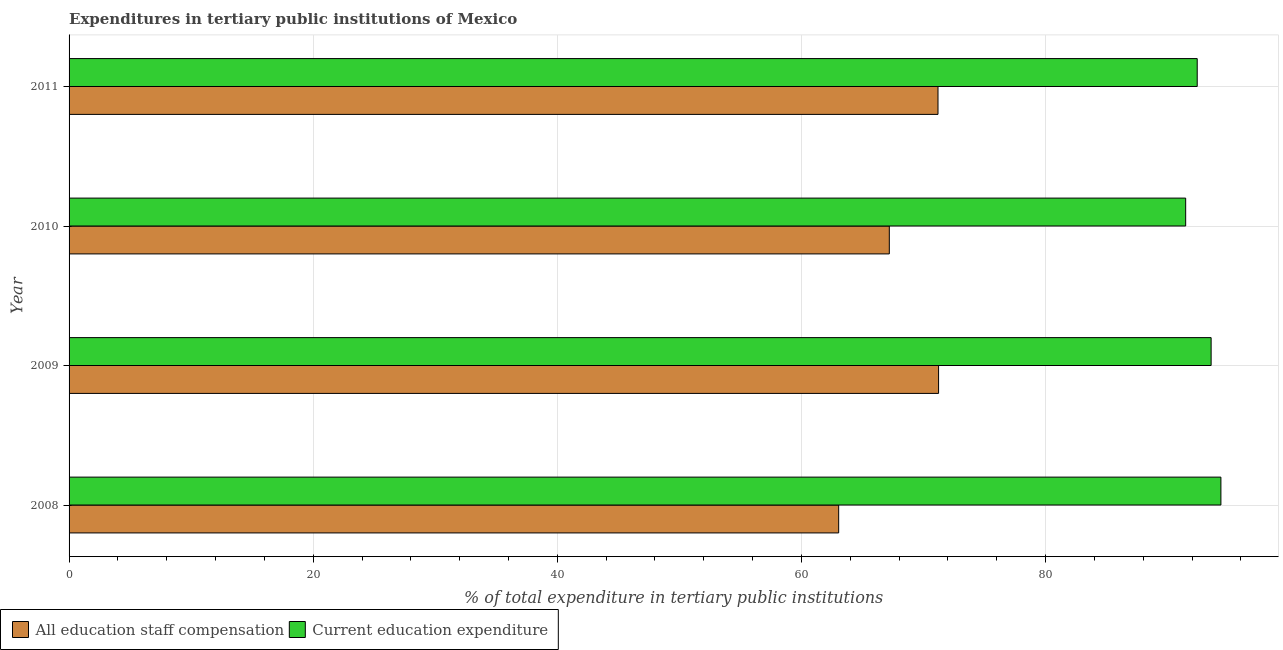How many different coloured bars are there?
Give a very brief answer. 2. How many groups of bars are there?
Keep it short and to the point. 4. Are the number of bars on each tick of the Y-axis equal?
Your answer should be very brief. Yes. How many bars are there on the 2nd tick from the top?
Ensure brevity in your answer.  2. What is the label of the 2nd group of bars from the top?
Offer a terse response. 2010. In how many cases, is the number of bars for a given year not equal to the number of legend labels?
Your response must be concise. 0. What is the expenditure in education in 2010?
Offer a terse response. 91.48. Across all years, what is the maximum expenditure in education?
Your response must be concise. 94.36. Across all years, what is the minimum expenditure in education?
Give a very brief answer. 91.48. In which year was the expenditure in education minimum?
Your response must be concise. 2010. What is the total expenditure in staff compensation in the graph?
Offer a very short reply. 272.67. What is the difference between the expenditure in education in 2008 and that in 2009?
Make the answer very short. 0.8. What is the difference between the expenditure in staff compensation in 2011 and the expenditure in education in 2008?
Offer a very short reply. -23.18. What is the average expenditure in staff compensation per year?
Offer a terse response. 68.17. In the year 2009, what is the difference between the expenditure in education and expenditure in staff compensation?
Your answer should be compact. 22.33. In how many years, is the expenditure in education greater than 68 %?
Your answer should be very brief. 4. What is the ratio of the expenditure in staff compensation in 2008 to that in 2010?
Provide a short and direct response. 0.94. Is the expenditure in staff compensation in 2008 less than that in 2011?
Ensure brevity in your answer.  Yes. Is the difference between the expenditure in education in 2009 and 2010 greater than the difference between the expenditure in staff compensation in 2009 and 2010?
Give a very brief answer. No. What is the difference between the highest and the second highest expenditure in staff compensation?
Make the answer very short. 0.05. What is the difference between the highest and the lowest expenditure in staff compensation?
Your response must be concise. 8.18. In how many years, is the expenditure in staff compensation greater than the average expenditure in staff compensation taken over all years?
Offer a very short reply. 2. What does the 1st bar from the top in 2009 represents?
Your answer should be very brief. Current education expenditure. What does the 1st bar from the bottom in 2008 represents?
Make the answer very short. All education staff compensation. How many bars are there?
Your answer should be compact. 8. Are the values on the major ticks of X-axis written in scientific E-notation?
Give a very brief answer. No. Does the graph contain any zero values?
Provide a short and direct response. No. How are the legend labels stacked?
Offer a very short reply. Horizontal. What is the title of the graph?
Provide a succinct answer. Expenditures in tertiary public institutions of Mexico. What is the label or title of the X-axis?
Provide a short and direct response. % of total expenditure in tertiary public institutions. What is the % of total expenditure in tertiary public institutions in All education staff compensation in 2008?
Make the answer very short. 63.05. What is the % of total expenditure in tertiary public institutions in Current education expenditure in 2008?
Ensure brevity in your answer.  94.36. What is the % of total expenditure in tertiary public institutions of All education staff compensation in 2009?
Provide a succinct answer. 71.23. What is the % of total expenditure in tertiary public institutions in Current education expenditure in 2009?
Provide a short and direct response. 93.56. What is the % of total expenditure in tertiary public institutions of All education staff compensation in 2010?
Offer a terse response. 67.2. What is the % of total expenditure in tertiary public institutions in Current education expenditure in 2010?
Offer a terse response. 91.48. What is the % of total expenditure in tertiary public institutions of All education staff compensation in 2011?
Provide a short and direct response. 71.19. What is the % of total expenditure in tertiary public institutions of Current education expenditure in 2011?
Provide a short and direct response. 92.42. Across all years, what is the maximum % of total expenditure in tertiary public institutions in All education staff compensation?
Provide a short and direct response. 71.23. Across all years, what is the maximum % of total expenditure in tertiary public institutions in Current education expenditure?
Your answer should be compact. 94.36. Across all years, what is the minimum % of total expenditure in tertiary public institutions in All education staff compensation?
Your answer should be compact. 63.05. Across all years, what is the minimum % of total expenditure in tertiary public institutions of Current education expenditure?
Keep it short and to the point. 91.48. What is the total % of total expenditure in tertiary public institutions of All education staff compensation in the graph?
Give a very brief answer. 272.67. What is the total % of total expenditure in tertiary public institutions of Current education expenditure in the graph?
Offer a terse response. 371.82. What is the difference between the % of total expenditure in tertiary public institutions in All education staff compensation in 2008 and that in 2009?
Offer a very short reply. -8.18. What is the difference between the % of total expenditure in tertiary public institutions of Current education expenditure in 2008 and that in 2009?
Provide a short and direct response. 0.8. What is the difference between the % of total expenditure in tertiary public institutions in All education staff compensation in 2008 and that in 2010?
Offer a very short reply. -4.15. What is the difference between the % of total expenditure in tertiary public institutions of Current education expenditure in 2008 and that in 2010?
Offer a very short reply. 2.89. What is the difference between the % of total expenditure in tertiary public institutions of All education staff compensation in 2008 and that in 2011?
Keep it short and to the point. -8.14. What is the difference between the % of total expenditure in tertiary public institutions in Current education expenditure in 2008 and that in 2011?
Your answer should be very brief. 1.94. What is the difference between the % of total expenditure in tertiary public institutions in All education staff compensation in 2009 and that in 2010?
Your answer should be compact. 4.04. What is the difference between the % of total expenditure in tertiary public institutions in Current education expenditure in 2009 and that in 2010?
Provide a short and direct response. 2.09. What is the difference between the % of total expenditure in tertiary public institutions of All education staff compensation in 2009 and that in 2011?
Ensure brevity in your answer.  0.05. What is the difference between the % of total expenditure in tertiary public institutions in Current education expenditure in 2009 and that in 2011?
Provide a succinct answer. 1.14. What is the difference between the % of total expenditure in tertiary public institutions in All education staff compensation in 2010 and that in 2011?
Give a very brief answer. -3.99. What is the difference between the % of total expenditure in tertiary public institutions of Current education expenditure in 2010 and that in 2011?
Your answer should be very brief. -0.95. What is the difference between the % of total expenditure in tertiary public institutions in All education staff compensation in 2008 and the % of total expenditure in tertiary public institutions in Current education expenditure in 2009?
Ensure brevity in your answer.  -30.51. What is the difference between the % of total expenditure in tertiary public institutions of All education staff compensation in 2008 and the % of total expenditure in tertiary public institutions of Current education expenditure in 2010?
Give a very brief answer. -28.43. What is the difference between the % of total expenditure in tertiary public institutions of All education staff compensation in 2008 and the % of total expenditure in tertiary public institutions of Current education expenditure in 2011?
Offer a terse response. -29.37. What is the difference between the % of total expenditure in tertiary public institutions in All education staff compensation in 2009 and the % of total expenditure in tertiary public institutions in Current education expenditure in 2010?
Your response must be concise. -20.24. What is the difference between the % of total expenditure in tertiary public institutions of All education staff compensation in 2009 and the % of total expenditure in tertiary public institutions of Current education expenditure in 2011?
Provide a succinct answer. -21.19. What is the difference between the % of total expenditure in tertiary public institutions of All education staff compensation in 2010 and the % of total expenditure in tertiary public institutions of Current education expenditure in 2011?
Give a very brief answer. -25.22. What is the average % of total expenditure in tertiary public institutions in All education staff compensation per year?
Offer a terse response. 68.17. What is the average % of total expenditure in tertiary public institutions of Current education expenditure per year?
Offer a terse response. 92.96. In the year 2008, what is the difference between the % of total expenditure in tertiary public institutions of All education staff compensation and % of total expenditure in tertiary public institutions of Current education expenditure?
Make the answer very short. -31.31. In the year 2009, what is the difference between the % of total expenditure in tertiary public institutions in All education staff compensation and % of total expenditure in tertiary public institutions in Current education expenditure?
Your answer should be compact. -22.33. In the year 2010, what is the difference between the % of total expenditure in tertiary public institutions in All education staff compensation and % of total expenditure in tertiary public institutions in Current education expenditure?
Offer a terse response. -24.28. In the year 2011, what is the difference between the % of total expenditure in tertiary public institutions of All education staff compensation and % of total expenditure in tertiary public institutions of Current education expenditure?
Your response must be concise. -21.24. What is the ratio of the % of total expenditure in tertiary public institutions in All education staff compensation in 2008 to that in 2009?
Your answer should be very brief. 0.89. What is the ratio of the % of total expenditure in tertiary public institutions of Current education expenditure in 2008 to that in 2009?
Keep it short and to the point. 1.01. What is the ratio of the % of total expenditure in tertiary public institutions in All education staff compensation in 2008 to that in 2010?
Your answer should be compact. 0.94. What is the ratio of the % of total expenditure in tertiary public institutions of Current education expenditure in 2008 to that in 2010?
Your answer should be very brief. 1.03. What is the ratio of the % of total expenditure in tertiary public institutions in All education staff compensation in 2008 to that in 2011?
Offer a very short reply. 0.89. What is the ratio of the % of total expenditure in tertiary public institutions of Current education expenditure in 2008 to that in 2011?
Provide a short and direct response. 1.02. What is the ratio of the % of total expenditure in tertiary public institutions of All education staff compensation in 2009 to that in 2010?
Your response must be concise. 1.06. What is the ratio of the % of total expenditure in tertiary public institutions of Current education expenditure in 2009 to that in 2010?
Offer a very short reply. 1.02. What is the ratio of the % of total expenditure in tertiary public institutions of Current education expenditure in 2009 to that in 2011?
Provide a succinct answer. 1.01. What is the ratio of the % of total expenditure in tertiary public institutions in All education staff compensation in 2010 to that in 2011?
Your response must be concise. 0.94. What is the ratio of the % of total expenditure in tertiary public institutions in Current education expenditure in 2010 to that in 2011?
Your answer should be very brief. 0.99. What is the difference between the highest and the second highest % of total expenditure in tertiary public institutions in All education staff compensation?
Provide a short and direct response. 0.05. What is the difference between the highest and the second highest % of total expenditure in tertiary public institutions in Current education expenditure?
Keep it short and to the point. 0.8. What is the difference between the highest and the lowest % of total expenditure in tertiary public institutions in All education staff compensation?
Offer a very short reply. 8.18. What is the difference between the highest and the lowest % of total expenditure in tertiary public institutions in Current education expenditure?
Make the answer very short. 2.89. 